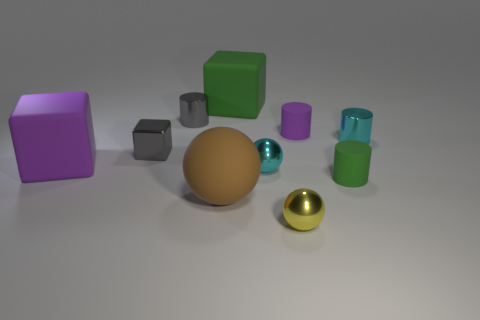Subtract all large purple rubber cubes. How many cubes are left? 2 Subtract all green cylinders. How many cylinders are left? 3 Subtract all cylinders. How many objects are left? 6 Subtract all yellow cubes. Subtract all red cylinders. How many cubes are left? 3 Add 6 small yellow metal balls. How many small yellow metal balls exist? 7 Subtract 0 brown cylinders. How many objects are left? 10 Subtract all small red cylinders. Subtract all cyan objects. How many objects are left? 8 Add 8 rubber balls. How many rubber balls are left? 9 